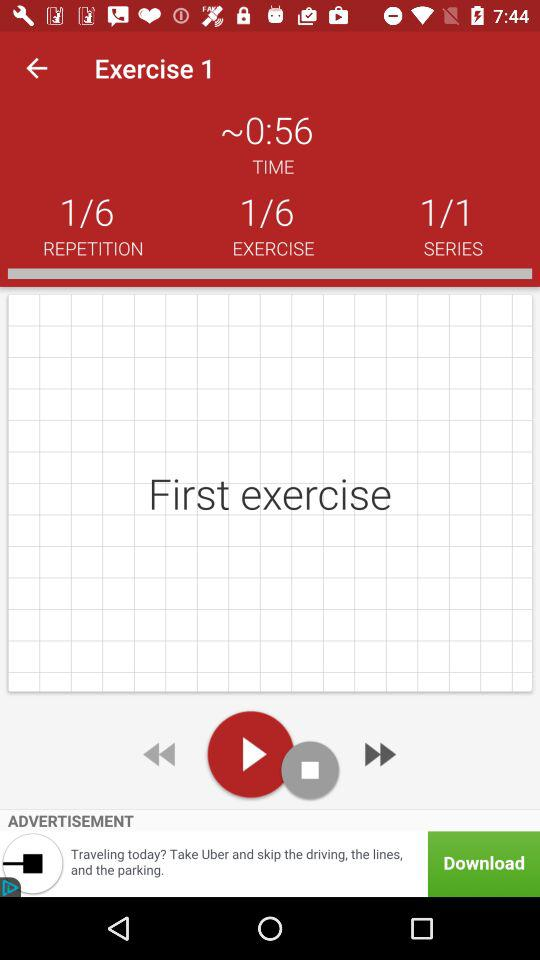What's the total number of repetitions of the exercise? The total number of repetitions of the exercise is 6. 